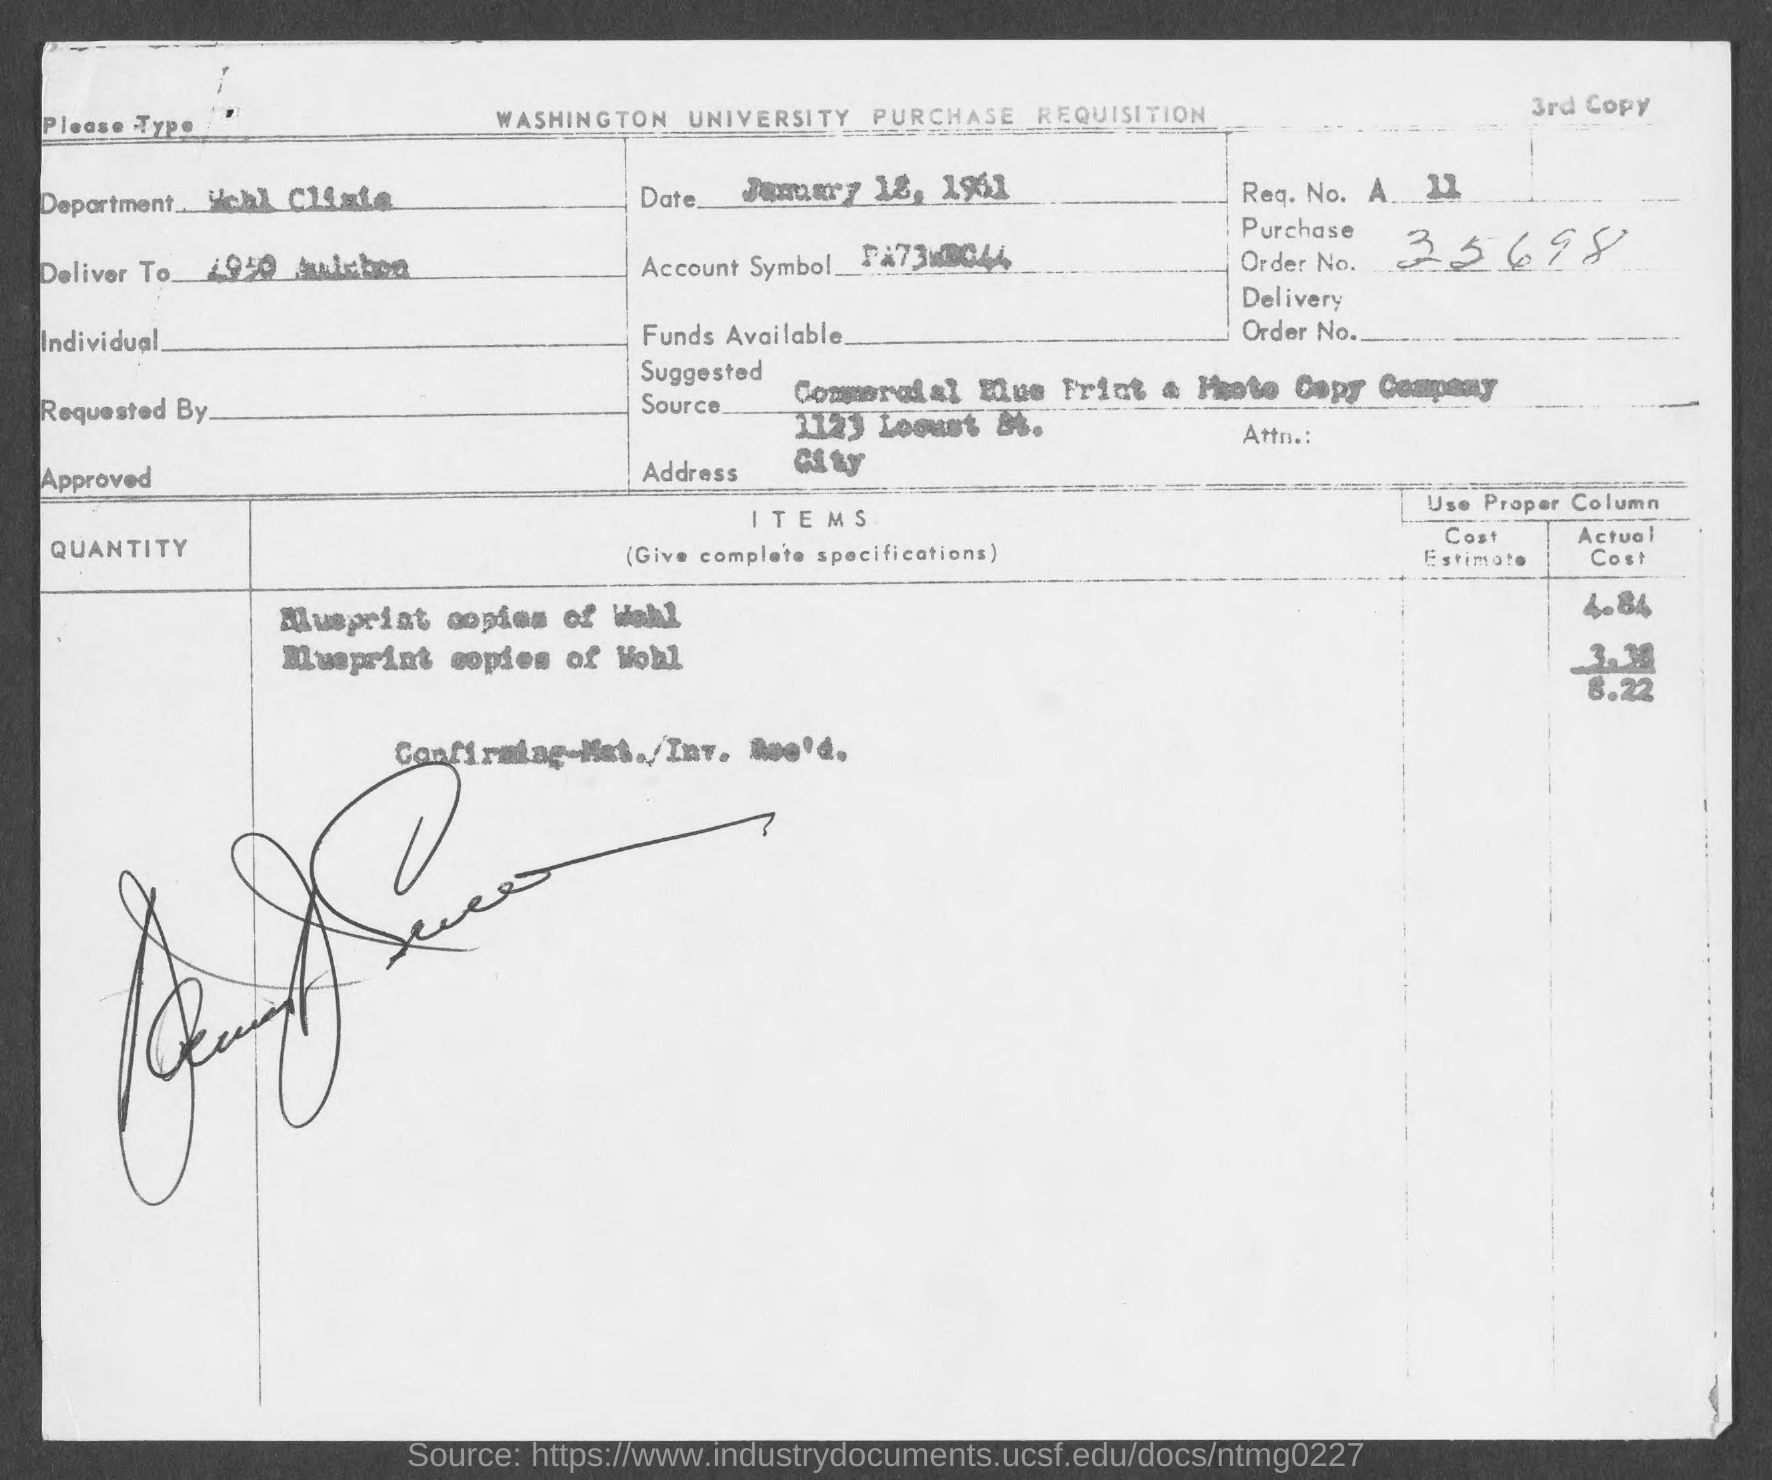What is the purchase order no.?
Make the answer very short. 35698. 